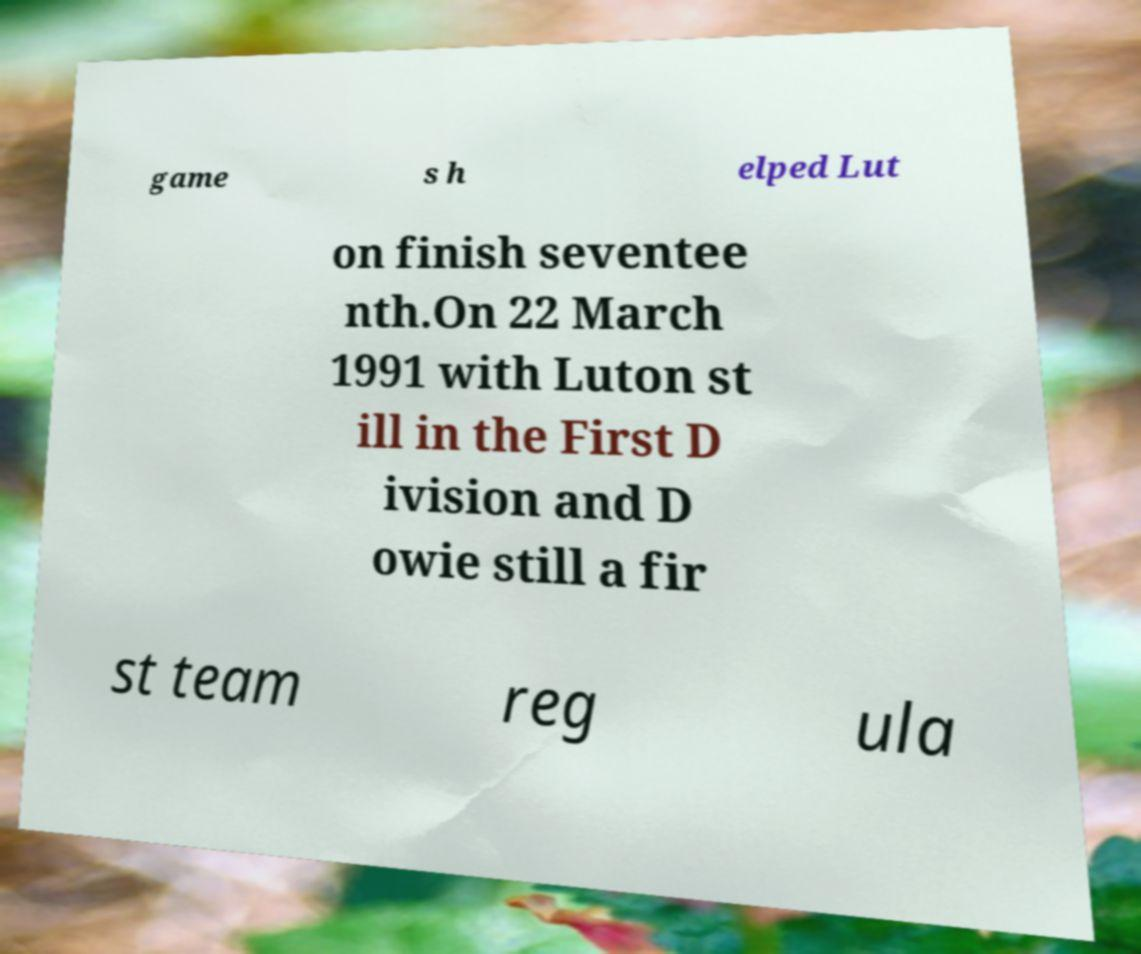Please identify and transcribe the text found in this image. game s h elped Lut on finish seventee nth.On 22 March 1991 with Luton st ill in the First D ivision and D owie still a fir st team reg ula 